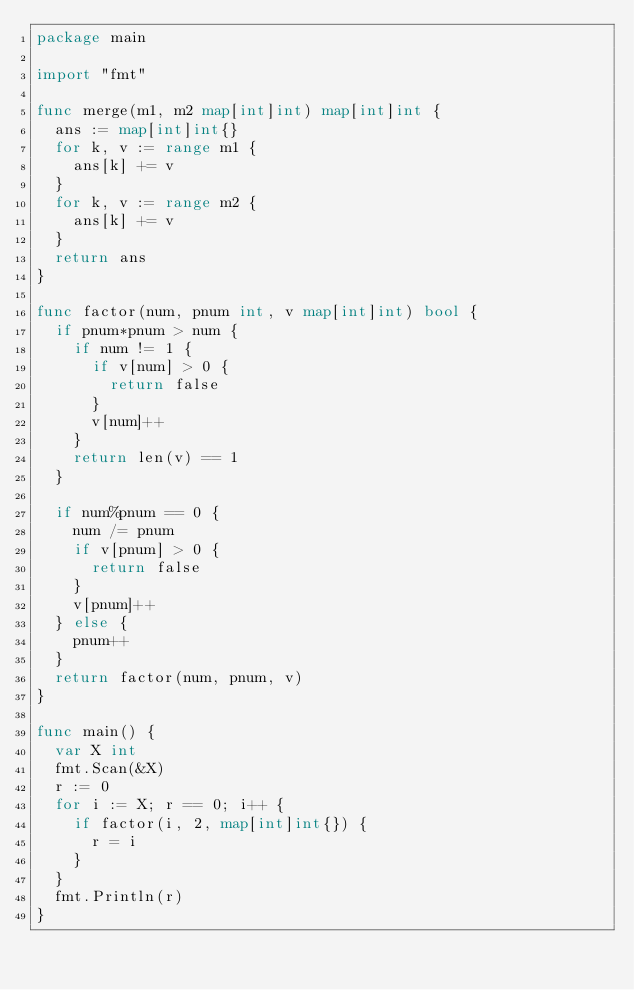<code> <loc_0><loc_0><loc_500><loc_500><_Go_>package main

import "fmt"

func merge(m1, m2 map[int]int) map[int]int {
	ans := map[int]int{}
	for k, v := range m1 {
		ans[k] += v
	}
	for k, v := range m2 {
		ans[k] += v
	}
	return ans
}

func factor(num, pnum int, v map[int]int) bool {
	if pnum*pnum > num {
		if num != 1 {
			if v[num] > 0 {
				return false
			}
			v[num]++
		}
		return len(v) == 1
	}

	if num%pnum == 0 {
		num /= pnum
		if v[pnum] > 0 {
			return false
		}
		v[pnum]++
	} else {
		pnum++
	}
	return factor(num, pnum, v)
}

func main() {
	var X int
	fmt.Scan(&X)
	r := 0
	for i := X; r == 0; i++ {
		if factor(i, 2, map[int]int{}) {
			r = i
		}
	}
	fmt.Println(r)
}
</code> 